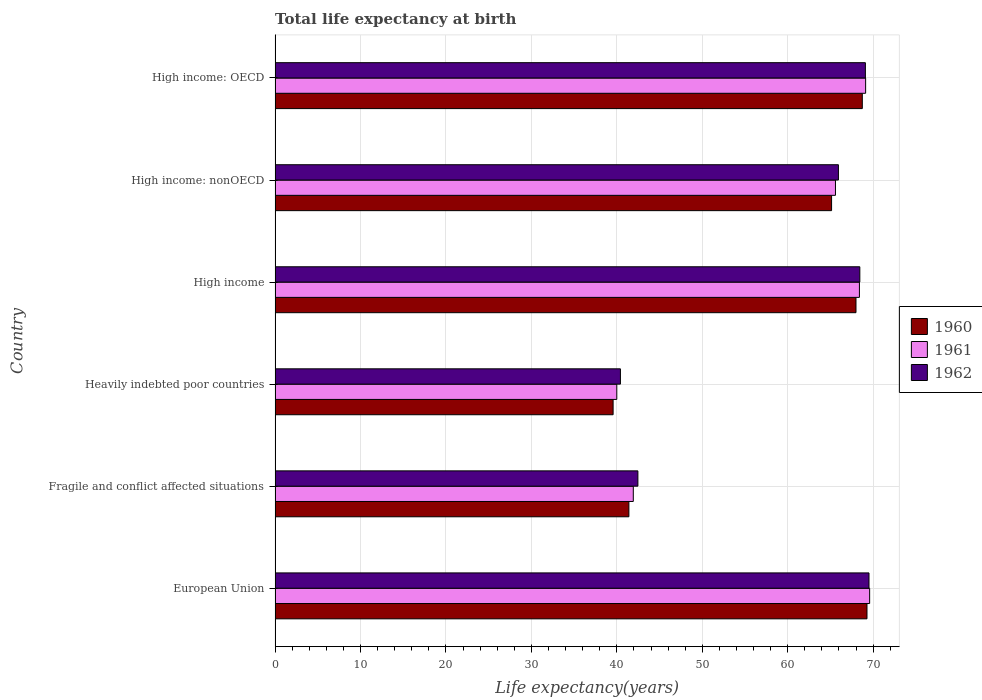How many different coloured bars are there?
Your answer should be very brief. 3. Are the number of bars per tick equal to the number of legend labels?
Offer a terse response. Yes. How many bars are there on the 3rd tick from the bottom?
Give a very brief answer. 3. What is the label of the 6th group of bars from the top?
Offer a terse response. European Union. In how many cases, is the number of bars for a given country not equal to the number of legend labels?
Offer a very short reply. 0. What is the life expectancy at birth in in 1960 in Heavily indebted poor countries?
Keep it short and to the point. 39.56. Across all countries, what is the maximum life expectancy at birth in in 1961?
Offer a terse response. 69.59. Across all countries, what is the minimum life expectancy at birth in in 1961?
Make the answer very short. 40. In which country was the life expectancy at birth in in 1961 minimum?
Offer a terse response. Heavily indebted poor countries. What is the total life expectancy at birth in in 1962 in the graph?
Your response must be concise. 355.87. What is the difference between the life expectancy at birth in in 1962 in European Union and that in Fragile and conflict affected situations?
Give a very brief answer. 27.05. What is the difference between the life expectancy at birth in in 1962 in European Union and the life expectancy at birth in in 1960 in High income: nonOECD?
Your response must be concise. 4.38. What is the average life expectancy at birth in in 1962 per country?
Make the answer very short. 59.31. What is the difference between the life expectancy at birth in in 1962 and life expectancy at birth in in 1961 in Heavily indebted poor countries?
Keep it short and to the point. 0.42. What is the ratio of the life expectancy at birth in in 1961 in Heavily indebted poor countries to that in High income?
Your answer should be very brief. 0.58. Is the life expectancy at birth in in 1961 in Fragile and conflict affected situations less than that in High income: nonOECD?
Offer a terse response. Yes. Is the difference between the life expectancy at birth in in 1962 in Heavily indebted poor countries and High income: nonOECD greater than the difference between the life expectancy at birth in in 1961 in Heavily indebted poor countries and High income: nonOECD?
Your answer should be compact. Yes. What is the difference between the highest and the second highest life expectancy at birth in in 1962?
Give a very brief answer. 0.42. What is the difference between the highest and the lowest life expectancy at birth in in 1962?
Make the answer very short. 29.1. How many countries are there in the graph?
Provide a succinct answer. 6. Are the values on the major ticks of X-axis written in scientific E-notation?
Provide a short and direct response. No. Where does the legend appear in the graph?
Keep it short and to the point. Center right. How many legend labels are there?
Your response must be concise. 3. What is the title of the graph?
Your answer should be very brief. Total life expectancy at birth. Does "2008" appear as one of the legend labels in the graph?
Your answer should be very brief. No. What is the label or title of the X-axis?
Provide a short and direct response. Life expectancy(years). What is the label or title of the Y-axis?
Ensure brevity in your answer.  Country. What is the Life expectancy(years) of 1960 in European Union?
Keep it short and to the point. 69.28. What is the Life expectancy(years) in 1961 in European Union?
Your answer should be very brief. 69.59. What is the Life expectancy(years) of 1962 in European Union?
Give a very brief answer. 69.51. What is the Life expectancy(years) of 1960 in Fragile and conflict affected situations?
Provide a succinct answer. 41.41. What is the Life expectancy(years) in 1961 in Fragile and conflict affected situations?
Offer a very short reply. 41.93. What is the Life expectancy(years) of 1962 in Fragile and conflict affected situations?
Provide a succinct answer. 42.47. What is the Life expectancy(years) of 1960 in Heavily indebted poor countries?
Keep it short and to the point. 39.56. What is the Life expectancy(years) of 1961 in Heavily indebted poor countries?
Give a very brief answer. 40. What is the Life expectancy(years) in 1962 in Heavily indebted poor countries?
Ensure brevity in your answer.  40.42. What is the Life expectancy(years) in 1960 in High income?
Keep it short and to the point. 67.99. What is the Life expectancy(years) in 1961 in High income?
Offer a terse response. 68.39. What is the Life expectancy(years) of 1962 in High income?
Give a very brief answer. 68.44. What is the Life expectancy(years) in 1960 in High income: nonOECD?
Ensure brevity in your answer.  65.13. What is the Life expectancy(years) of 1961 in High income: nonOECD?
Provide a short and direct response. 65.59. What is the Life expectancy(years) in 1962 in High income: nonOECD?
Offer a terse response. 65.94. What is the Life expectancy(years) of 1960 in High income: OECD?
Offer a terse response. 68.73. What is the Life expectancy(years) in 1961 in High income: OECD?
Provide a short and direct response. 69.12. What is the Life expectancy(years) of 1962 in High income: OECD?
Make the answer very short. 69.09. Across all countries, what is the maximum Life expectancy(years) in 1960?
Your answer should be very brief. 69.28. Across all countries, what is the maximum Life expectancy(years) in 1961?
Your answer should be compact. 69.59. Across all countries, what is the maximum Life expectancy(years) of 1962?
Offer a very short reply. 69.51. Across all countries, what is the minimum Life expectancy(years) in 1960?
Make the answer very short. 39.56. Across all countries, what is the minimum Life expectancy(years) of 1961?
Give a very brief answer. 40. Across all countries, what is the minimum Life expectancy(years) in 1962?
Provide a short and direct response. 40.42. What is the total Life expectancy(years) in 1960 in the graph?
Your response must be concise. 352.11. What is the total Life expectancy(years) in 1961 in the graph?
Offer a terse response. 354.62. What is the total Life expectancy(years) in 1962 in the graph?
Offer a very short reply. 355.87. What is the difference between the Life expectancy(years) in 1960 in European Union and that in Fragile and conflict affected situations?
Your answer should be compact. 27.87. What is the difference between the Life expectancy(years) of 1961 in European Union and that in Fragile and conflict affected situations?
Provide a short and direct response. 27.66. What is the difference between the Life expectancy(years) in 1962 in European Union and that in Fragile and conflict affected situations?
Provide a succinct answer. 27.05. What is the difference between the Life expectancy(years) in 1960 in European Union and that in Heavily indebted poor countries?
Ensure brevity in your answer.  29.72. What is the difference between the Life expectancy(years) in 1961 in European Union and that in Heavily indebted poor countries?
Provide a succinct answer. 29.59. What is the difference between the Life expectancy(years) of 1962 in European Union and that in Heavily indebted poor countries?
Provide a short and direct response. 29.1. What is the difference between the Life expectancy(years) in 1960 in European Union and that in High income?
Your answer should be compact. 1.29. What is the difference between the Life expectancy(years) in 1961 in European Union and that in High income?
Provide a short and direct response. 1.2. What is the difference between the Life expectancy(years) of 1962 in European Union and that in High income?
Offer a terse response. 1.07. What is the difference between the Life expectancy(years) in 1960 in European Union and that in High income: nonOECD?
Your response must be concise. 4.14. What is the difference between the Life expectancy(years) in 1961 in European Union and that in High income: nonOECD?
Your answer should be very brief. 4. What is the difference between the Life expectancy(years) in 1962 in European Union and that in High income: nonOECD?
Offer a terse response. 3.58. What is the difference between the Life expectancy(years) of 1960 in European Union and that in High income: OECD?
Your answer should be compact. 0.55. What is the difference between the Life expectancy(years) in 1961 in European Union and that in High income: OECD?
Provide a succinct answer. 0.47. What is the difference between the Life expectancy(years) in 1962 in European Union and that in High income: OECD?
Offer a terse response. 0.42. What is the difference between the Life expectancy(years) of 1960 in Fragile and conflict affected situations and that in Heavily indebted poor countries?
Offer a very short reply. 1.85. What is the difference between the Life expectancy(years) in 1961 in Fragile and conflict affected situations and that in Heavily indebted poor countries?
Your answer should be compact. 1.93. What is the difference between the Life expectancy(years) of 1962 in Fragile and conflict affected situations and that in Heavily indebted poor countries?
Your answer should be very brief. 2.05. What is the difference between the Life expectancy(years) of 1960 in Fragile and conflict affected situations and that in High income?
Give a very brief answer. -26.58. What is the difference between the Life expectancy(years) in 1961 in Fragile and conflict affected situations and that in High income?
Provide a short and direct response. -26.47. What is the difference between the Life expectancy(years) of 1962 in Fragile and conflict affected situations and that in High income?
Make the answer very short. -25.98. What is the difference between the Life expectancy(years) in 1960 in Fragile and conflict affected situations and that in High income: nonOECD?
Make the answer very short. -23.72. What is the difference between the Life expectancy(years) in 1961 in Fragile and conflict affected situations and that in High income: nonOECD?
Give a very brief answer. -23.66. What is the difference between the Life expectancy(years) of 1962 in Fragile and conflict affected situations and that in High income: nonOECD?
Make the answer very short. -23.47. What is the difference between the Life expectancy(years) of 1960 in Fragile and conflict affected situations and that in High income: OECD?
Provide a succinct answer. -27.32. What is the difference between the Life expectancy(years) of 1961 in Fragile and conflict affected situations and that in High income: OECD?
Offer a very short reply. -27.19. What is the difference between the Life expectancy(years) in 1962 in Fragile and conflict affected situations and that in High income: OECD?
Offer a very short reply. -26.63. What is the difference between the Life expectancy(years) of 1960 in Heavily indebted poor countries and that in High income?
Ensure brevity in your answer.  -28.43. What is the difference between the Life expectancy(years) of 1961 in Heavily indebted poor countries and that in High income?
Your response must be concise. -28.4. What is the difference between the Life expectancy(years) of 1962 in Heavily indebted poor countries and that in High income?
Give a very brief answer. -28.02. What is the difference between the Life expectancy(years) of 1960 in Heavily indebted poor countries and that in High income: nonOECD?
Offer a terse response. -25.57. What is the difference between the Life expectancy(years) of 1961 in Heavily indebted poor countries and that in High income: nonOECD?
Make the answer very short. -25.59. What is the difference between the Life expectancy(years) of 1962 in Heavily indebted poor countries and that in High income: nonOECD?
Provide a short and direct response. -25.52. What is the difference between the Life expectancy(years) in 1960 in Heavily indebted poor countries and that in High income: OECD?
Keep it short and to the point. -29.17. What is the difference between the Life expectancy(years) in 1961 in Heavily indebted poor countries and that in High income: OECD?
Offer a very short reply. -29.12. What is the difference between the Life expectancy(years) in 1962 in Heavily indebted poor countries and that in High income: OECD?
Your answer should be very brief. -28.67. What is the difference between the Life expectancy(years) of 1960 in High income and that in High income: nonOECD?
Ensure brevity in your answer.  2.86. What is the difference between the Life expectancy(years) in 1961 in High income and that in High income: nonOECD?
Keep it short and to the point. 2.8. What is the difference between the Life expectancy(years) of 1962 in High income and that in High income: nonOECD?
Give a very brief answer. 2.51. What is the difference between the Life expectancy(years) of 1960 in High income and that in High income: OECD?
Make the answer very short. -0.74. What is the difference between the Life expectancy(years) of 1961 in High income and that in High income: OECD?
Provide a succinct answer. -0.73. What is the difference between the Life expectancy(years) of 1962 in High income and that in High income: OECD?
Make the answer very short. -0.65. What is the difference between the Life expectancy(years) of 1960 in High income: nonOECD and that in High income: OECD?
Make the answer very short. -3.6. What is the difference between the Life expectancy(years) of 1961 in High income: nonOECD and that in High income: OECD?
Make the answer very short. -3.53. What is the difference between the Life expectancy(years) in 1962 in High income: nonOECD and that in High income: OECD?
Keep it short and to the point. -3.16. What is the difference between the Life expectancy(years) in 1960 in European Union and the Life expectancy(years) in 1961 in Fragile and conflict affected situations?
Your answer should be very brief. 27.35. What is the difference between the Life expectancy(years) of 1960 in European Union and the Life expectancy(years) of 1962 in Fragile and conflict affected situations?
Offer a very short reply. 26.81. What is the difference between the Life expectancy(years) of 1961 in European Union and the Life expectancy(years) of 1962 in Fragile and conflict affected situations?
Your answer should be very brief. 27.12. What is the difference between the Life expectancy(years) of 1960 in European Union and the Life expectancy(years) of 1961 in Heavily indebted poor countries?
Ensure brevity in your answer.  29.28. What is the difference between the Life expectancy(years) of 1960 in European Union and the Life expectancy(years) of 1962 in Heavily indebted poor countries?
Your response must be concise. 28.86. What is the difference between the Life expectancy(years) of 1961 in European Union and the Life expectancy(years) of 1962 in Heavily indebted poor countries?
Ensure brevity in your answer.  29.17. What is the difference between the Life expectancy(years) in 1960 in European Union and the Life expectancy(years) in 1961 in High income?
Offer a terse response. 0.89. What is the difference between the Life expectancy(years) of 1960 in European Union and the Life expectancy(years) of 1962 in High income?
Your response must be concise. 0.84. What is the difference between the Life expectancy(years) in 1961 in European Union and the Life expectancy(years) in 1962 in High income?
Provide a short and direct response. 1.15. What is the difference between the Life expectancy(years) in 1960 in European Union and the Life expectancy(years) in 1961 in High income: nonOECD?
Make the answer very short. 3.69. What is the difference between the Life expectancy(years) of 1960 in European Union and the Life expectancy(years) of 1962 in High income: nonOECD?
Your answer should be compact. 3.34. What is the difference between the Life expectancy(years) of 1961 in European Union and the Life expectancy(years) of 1962 in High income: nonOECD?
Give a very brief answer. 3.65. What is the difference between the Life expectancy(years) in 1960 in European Union and the Life expectancy(years) in 1961 in High income: OECD?
Offer a very short reply. 0.16. What is the difference between the Life expectancy(years) of 1960 in European Union and the Life expectancy(years) of 1962 in High income: OECD?
Offer a terse response. 0.19. What is the difference between the Life expectancy(years) in 1961 in European Union and the Life expectancy(years) in 1962 in High income: OECD?
Your answer should be compact. 0.5. What is the difference between the Life expectancy(years) of 1960 in Fragile and conflict affected situations and the Life expectancy(years) of 1961 in Heavily indebted poor countries?
Give a very brief answer. 1.42. What is the difference between the Life expectancy(years) in 1960 in Fragile and conflict affected situations and the Life expectancy(years) in 1962 in Heavily indebted poor countries?
Ensure brevity in your answer.  0.99. What is the difference between the Life expectancy(years) of 1961 in Fragile and conflict affected situations and the Life expectancy(years) of 1962 in Heavily indebted poor countries?
Ensure brevity in your answer.  1.51. What is the difference between the Life expectancy(years) of 1960 in Fragile and conflict affected situations and the Life expectancy(years) of 1961 in High income?
Provide a short and direct response. -26.98. What is the difference between the Life expectancy(years) in 1960 in Fragile and conflict affected situations and the Life expectancy(years) in 1962 in High income?
Your answer should be compact. -27.03. What is the difference between the Life expectancy(years) of 1961 in Fragile and conflict affected situations and the Life expectancy(years) of 1962 in High income?
Give a very brief answer. -26.51. What is the difference between the Life expectancy(years) in 1960 in Fragile and conflict affected situations and the Life expectancy(years) in 1961 in High income: nonOECD?
Your answer should be very brief. -24.18. What is the difference between the Life expectancy(years) in 1960 in Fragile and conflict affected situations and the Life expectancy(years) in 1962 in High income: nonOECD?
Your answer should be compact. -24.52. What is the difference between the Life expectancy(years) in 1961 in Fragile and conflict affected situations and the Life expectancy(years) in 1962 in High income: nonOECD?
Provide a short and direct response. -24.01. What is the difference between the Life expectancy(years) in 1960 in Fragile and conflict affected situations and the Life expectancy(years) in 1961 in High income: OECD?
Give a very brief answer. -27.71. What is the difference between the Life expectancy(years) of 1960 in Fragile and conflict affected situations and the Life expectancy(years) of 1962 in High income: OECD?
Your response must be concise. -27.68. What is the difference between the Life expectancy(years) in 1961 in Fragile and conflict affected situations and the Life expectancy(years) in 1962 in High income: OECD?
Offer a very short reply. -27.16. What is the difference between the Life expectancy(years) of 1960 in Heavily indebted poor countries and the Life expectancy(years) of 1961 in High income?
Your response must be concise. -28.83. What is the difference between the Life expectancy(years) in 1960 in Heavily indebted poor countries and the Life expectancy(years) in 1962 in High income?
Your answer should be compact. -28.88. What is the difference between the Life expectancy(years) in 1961 in Heavily indebted poor countries and the Life expectancy(years) in 1962 in High income?
Provide a short and direct response. -28.45. What is the difference between the Life expectancy(years) of 1960 in Heavily indebted poor countries and the Life expectancy(years) of 1961 in High income: nonOECD?
Offer a very short reply. -26.03. What is the difference between the Life expectancy(years) in 1960 in Heavily indebted poor countries and the Life expectancy(years) in 1962 in High income: nonOECD?
Your answer should be very brief. -26.37. What is the difference between the Life expectancy(years) in 1961 in Heavily indebted poor countries and the Life expectancy(years) in 1962 in High income: nonOECD?
Your answer should be compact. -25.94. What is the difference between the Life expectancy(years) of 1960 in Heavily indebted poor countries and the Life expectancy(years) of 1961 in High income: OECD?
Offer a very short reply. -29.56. What is the difference between the Life expectancy(years) in 1960 in Heavily indebted poor countries and the Life expectancy(years) in 1962 in High income: OECD?
Make the answer very short. -29.53. What is the difference between the Life expectancy(years) in 1961 in Heavily indebted poor countries and the Life expectancy(years) in 1962 in High income: OECD?
Provide a short and direct response. -29.1. What is the difference between the Life expectancy(years) in 1960 in High income and the Life expectancy(years) in 1961 in High income: nonOECD?
Offer a very short reply. 2.4. What is the difference between the Life expectancy(years) in 1960 in High income and the Life expectancy(years) in 1962 in High income: nonOECD?
Offer a terse response. 2.06. What is the difference between the Life expectancy(years) in 1961 in High income and the Life expectancy(years) in 1962 in High income: nonOECD?
Ensure brevity in your answer.  2.46. What is the difference between the Life expectancy(years) in 1960 in High income and the Life expectancy(years) in 1961 in High income: OECD?
Keep it short and to the point. -1.13. What is the difference between the Life expectancy(years) of 1960 in High income and the Life expectancy(years) of 1962 in High income: OECD?
Your response must be concise. -1.1. What is the difference between the Life expectancy(years) in 1961 in High income and the Life expectancy(years) in 1962 in High income: OECD?
Your answer should be very brief. -0.7. What is the difference between the Life expectancy(years) in 1960 in High income: nonOECD and the Life expectancy(years) in 1961 in High income: OECD?
Your response must be concise. -3.98. What is the difference between the Life expectancy(years) of 1960 in High income: nonOECD and the Life expectancy(years) of 1962 in High income: OECD?
Provide a short and direct response. -3.96. What is the difference between the Life expectancy(years) of 1961 in High income: nonOECD and the Life expectancy(years) of 1962 in High income: OECD?
Keep it short and to the point. -3.5. What is the average Life expectancy(years) in 1960 per country?
Provide a succinct answer. 58.69. What is the average Life expectancy(years) in 1961 per country?
Offer a very short reply. 59.1. What is the average Life expectancy(years) of 1962 per country?
Provide a short and direct response. 59.31. What is the difference between the Life expectancy(years) of 1960 and Life expectancy(years) of 1961 in European Union?
Offer a very short reply. -0.31. What is the difference between the Life expectancy(years) of 1960 and Life expectancy(years) of 1962 in European Union?
Provide a succinct answer. -0.23. What is the difference between the Life expectancy(years) in 1961 and Life expectancy(years) in 1962 in European Union?
Make the answer very short. 0.07. What is the difference between the Life expectancy(years) in 1960 and Life expectancy(years) in 1961 in Fragile and conflict affected situations?
Make the answer very short. -0.52. What is the difference between the Life expectancy(years) in 1960 and Life expectancy(years) in 1962 in Fragile and conflict affected situations?
Ensure brevity in your answer.  -1.05. What is the difference between the Life expectancy(years) of 1961 and Life expectancy(years) of 1962 in Fragile and conflict affected situations?
Give a very brief answer. -0.54. What is the difference between the Life expectancy(years) of 1960 and Life expectancy(years) of 1961 in Heavily indebted poor countries?
Make the answer very short. -0.43. What is the difference between the Life expectancy(years) of 1960 and Life expectancy(years) of 1962 in Heavily indebted poor countries?
Your response must be concise. -0.86. What is the difference between the Life expectancy(years) in 1961 and Life expectancy(years) in 1962 in Heavily indebted poor countries?
Offer a very short reply. -0.42. What is the difference between the Life expectancy(years) of 1960 and Life expectancy(years) of 1961 in High income?
Your response must be concise. -0.4. What is the difference between the Life expectancy(years) in 1960 and Life expectancy(years) in 1962 in High income?
Offer a terse response. -0.45. What is the difference between the Life expectancy(years) in 1961 and Life expectancy(years) in 1962 in High income?
Give a very brief answer. -0.05. What is the difference between the Life expectancy(years) in 1960 and Life expectancy(years) in 1961 in High income: nonOECD?
Ensure brevity in your answer.  -0.46. What is the difference between the Life expectancy(years) in 1960 and Life expectancy(years) in 1962 in High income: nonOECD?
Give a very brief answer. -0.8. What is the difference between the Life expectancy(years) in 1961 and Life expectancy(years) in 1962 in High income: nonOECD?
Keep it short and to the point. -0.35. What is the difference between the Life expectancy(years) in 1960 and Life expectancy(years) in 1961 in High income: OECD?
Make the answer very short. -0.39. What is the difference between the Life expectancy(years) in 1960 and Life expectancy(years) in 1962 in High income: OECD?
Offer a terse response. -0.36. What is the difference between the Life expectancy(years) in 1961 and Life expectancy(years) in 1962 in High income: OECD?
Your response must be concise. 0.03. What is the ratio of the Life expectancy(years) in 1960 in European Union to that in Fragile and conflict affected situations?
Provide a succinct answer. 1.67. What is the ratio of the Life expectancy(years) of 1961 in European Union to that in Fragile and conflict affected situations?
Offer a terse response. 1.66. What is the ratio of the Life expectancy(years) in 1962 in European Union to that in Fragile and conflict affected situations?
Keep it short and to the point. 1.64. What is the ratio of the Life expectancy(years) in 1960 in European Union to that in Heavily indebted poor countries?
Make the answer very short. 1.75. What is the ratio of the Life expectancy(years) in 1961 in European Union to that in Heavily indebted poor countries?
Keep it short and to the point. 1.74. What is the ratio of the Life expectancy(years) of 1962 in European Union to that in Heavily indebted poor countries?
Your answer should be compact. 1.72. What is the ratio of the Life expectancy(years) of 1960 in European Union to that in High income?
Your response must be concise. 1.02. What is the ratio of the Life expectancy(years) of 1961 in European Union to that in High income?
Your answer should be compact. 1.02. What is the ratio of the Life expectancy(years) in 1962 in European Union to that in High income?
Provide a short and direct response. 1.02. What is the ratio of the Life expectancy(years) of 1960 in European Union to that in High income: nonOECD?
Give a very brief answer. 1.06. What is the ratio of the Life expectancy(years) of 1961 in European Union to that in High income: nonOECD?
Offer a very short reply. 1.06. What is the ratio of the Life expectancy(years) of 1962 in European Union to that in High income: nonOECD?
Your answer should be very brief. 1.05. What is the ratio of the Life expectancy(years) in 1961 in European Union to that in High income: OECD?
Provide a short and direct response. 1.01. What is the ratio of the Life expectancy(years) of 1962 in European Union to that in High income: OECD?
Offer a terse response. 1.01. What is the ratio of the Life expectancy(years) of 1960 in Fragile and conflict affected situations to that in Heavily indebted poor countries?
Your answer should be very brief. 1.05. What is the ratio of the Life expectancy(years) of 1961 in Fragile and conflict affected situations to that in Heavily indebted poor countries?
Provide a short and direct response. 1.05. What is the ratio of the Life expectancy(years) of 1962 in Fragile and conflict affected situations to that in Heavily indebted poor countries?
Provide a succinct answer. 1.05. What is the ratio of the Life expectancy(years) in 1960 in Fragile and conflict affected situations to that in High income?
Provide a succinct answer. 0.61. What is the ratio of the Life expectancy(years) of 1961 in Fragile and conflict affected situations to that in High income?
Offer a very short reply. 0.61. What is the ratio of the Life expectancy(years) of 1962 in Fragile and conflict affected situations to that in High income?
Keep it short and to the point. 0.62. What is the ratio of the Life expectancy(years) of 1960 in Fragile and conflict affected situations to that in High income: nonOECD?
Offer a terse response. 0.64. What is the ratio of the Life expectancy(years) in 1961 in Fragile and conflict affected situations to that in High income: nonOECD?
Offer a very short reply. 0.64. What is the ratio of the Life expectancy(years) of 1962 in Fragile and conflict affected situations to that in High income: nonOECD?
Make the answer very short. 0.64. What is the ratio of the Life expectancy(years) in 1960 in Fragile and conflict affected situations to that in High income: OECD?
Make the answer very short. 0.6. What is the ratio of the Life expectancy(years) of 1961 in Fragile and conflict affected situations to that in High income: OECD?
Your response must be concise. 0.61. What is the ratio of the Life expectancy(years) of 1962 in Fragile and conflict affected situations to that in High income: OECD?
Offer a terse response. 0.61. What is the ratio of the Life expectancy(years) of 1960 in Heavily indebted poor countries to that in High income?
Make the answer very short. 0.58. What is the ratio of the Life expectancy(years) in 1961 in Heavily indebted poor countries to that in High income?
Your response must be concise. 0.58. What is the ratio of the Life expectancy(years) in 1962 in Heavily indebted poor countries to that in High income?
Your answer should be compact. 0.59. What is the ratio of the Life expectancy(years) of 1960 in Heavily indebted poor countries to that in High income: nonOECD?
Your answer should be compact. 0.61. What is the ratio of the Life expectancy(years) in 1961 in Heavily indebted poor countries to that in High income: nonOECD?
Provide a short and direct response. 0.61. What is the ratio of the Life expectancy(years) of 1962 in Heavily indebted poor countries to that in High income: nonOECD?
Make the answer very short. 0.61. What is the ratio of the Life expectancy(years) of 1960 in Heavily indebted poor countries to that in High income: OECD?
Make the answer very short. 0.58. What is the ratio of the Life expectancy(years) in 1961 in Heavily indebted poor countries to that in High income: OECD?
Your answer should be compact. 0.58. What is the ratio of the Life expectancy(years) in 1962 in Heavily indebted poor countries to that in High income: OECD?
Offer a terse response. 0.58. What is the ratio of the Life expectancy(years) of 1960 in High income to that in High income: nonOECD?
Your answer should be very brief. 1.04. What is the ratio of the Life expectancy(years) in 1961 in High income to that in High income: nonOECD?
Your answer should be compact. 1.04. What is the ratio of the Life expectancy(years) of 1962 in High income to that in High income: nonOECD?
Provide a short and direct response. 1.04. What is the ratio of the Life expectancy(years) of 1961 in High income to that in High income: OECD?
Your response must be concise. 0.99. What is the ratio of the Life expectancy(years) in 1962 in High income to that in High income: OECD?
Keep it short and to the point. 0.99. What is the ratio of the Life expectancy(years) of 1960 in High income: nonOECD to that in High income: OECD?
Give a very brief answer. 0.95. What is the ratio of the Life expectancy(years) of 1961 in High income: nonOECD to that in High income: OECD?
Your answer should be very brief. 0.95. What is the ratio of the Life expectancy(years) of 1962 in High income: nonOECD to that in High income: OECD?
Provide a short and direct response. 0.95. What is the difference between the highest and the second highest Life expectancy(years) of 1960?
Make the answer very short. 0.55. What is the difference between the highest and the second highest Life expectancy(years) in 1961?
Make the answer very short. 0.47. What is the difference between the highest and the second highest Life expectancy(years) of 1962?
Keep it short and to the point. 0.42. What is the difference between the highest and the lowest Life expectancy(years) in 1960?
Offer a very short reply. 29.72. What is the difference between the highest and the lowest Life expectancy(years) of 1961?
Give a very brief answer. 29.59. What is the difference between the highest and the lowest Life expectancy(years) in 1962?
Provide a succinct answer. 29.1. 